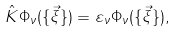Convert formula to latex. <formula><loc_0><loc_0><loc_500><loc_500>\hat { K } \Phi _ { \nu } ( \{ \vec { \xi } \} ) = \varepsilon _ { \nu } \Phi _ { \nu } ( \{ \vec { \xi } \} ) ,</formula> 